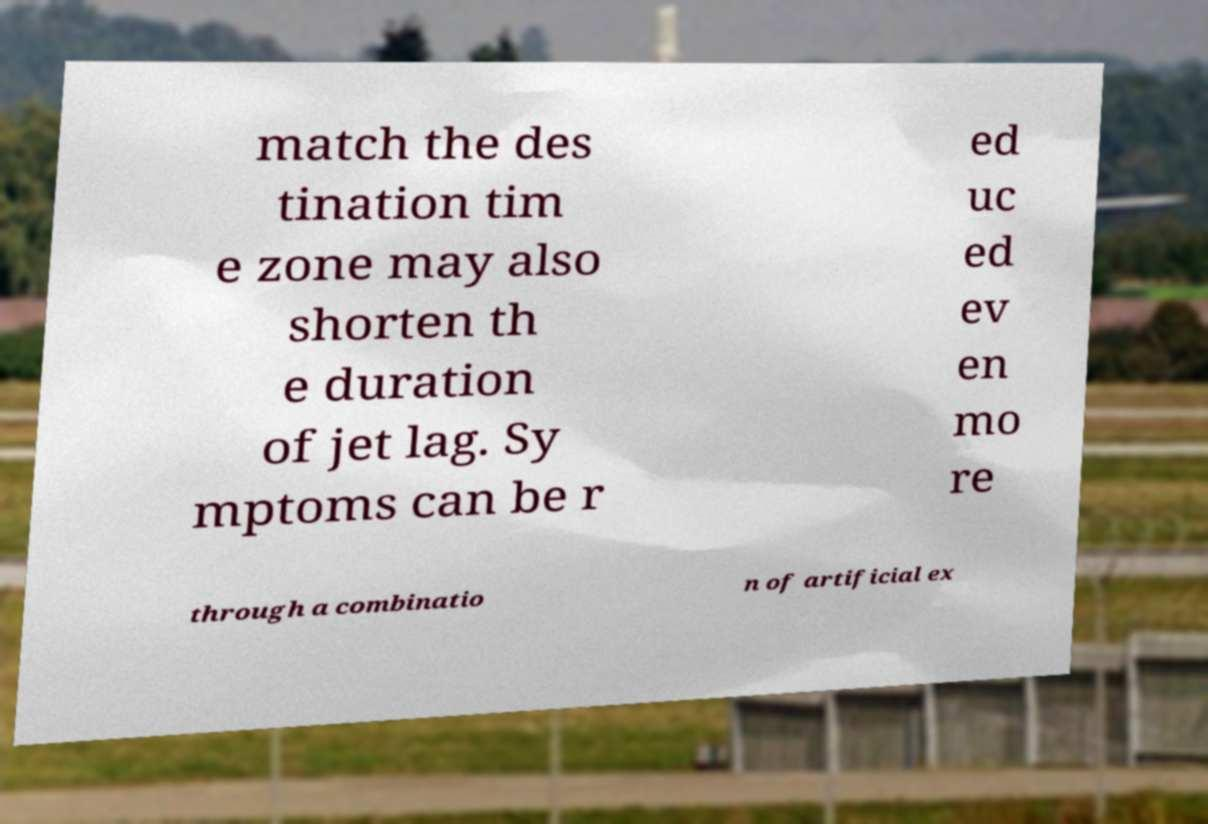Please identify and transcribe the text found in this image. match the des tination tim e zone may also shorten th e duration of jet lag. Sy mptoms can be r ed uc ed ev en mo re through a combinatio n of artificial ex 